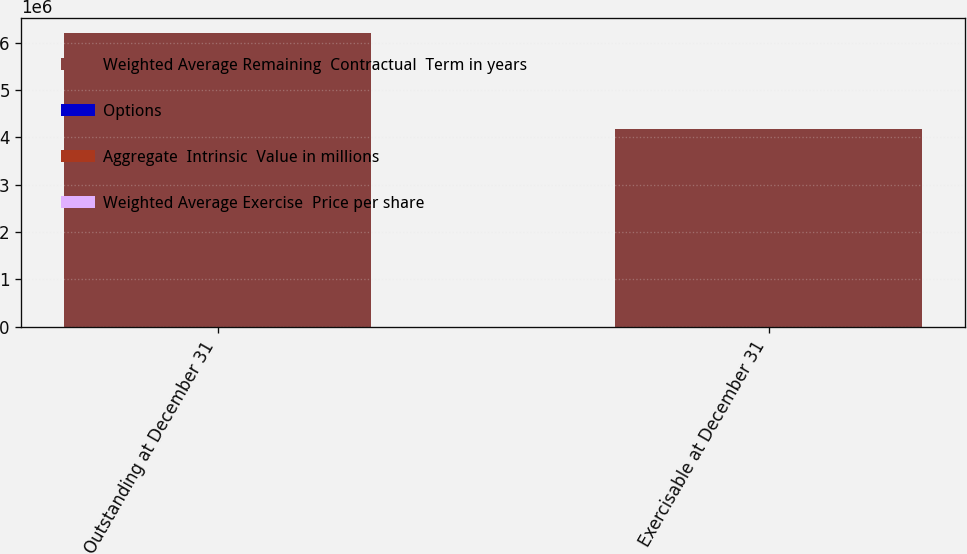<chart> <loc_0><loc_0><loc_500><loc_500><stacked_bar_chart><ecel><fcel>Outstanding at December 31<fcel>Exercisable at December 31<nl><fcel>Weighted Average Remaining  Contractual  Term in years<fcel>6.20579e+06<fcel>4.16444e+06<nl><fcel>Options<fcel>70.27<fcel>58.34<nl><fcel>Aggregate  Intrinsic  Value in millions<fcel>6.2<fcel>5.1<nl><fcel>Weighted Average Exercise  Price per share<fcel>196<fcel>181<nl></chart> 